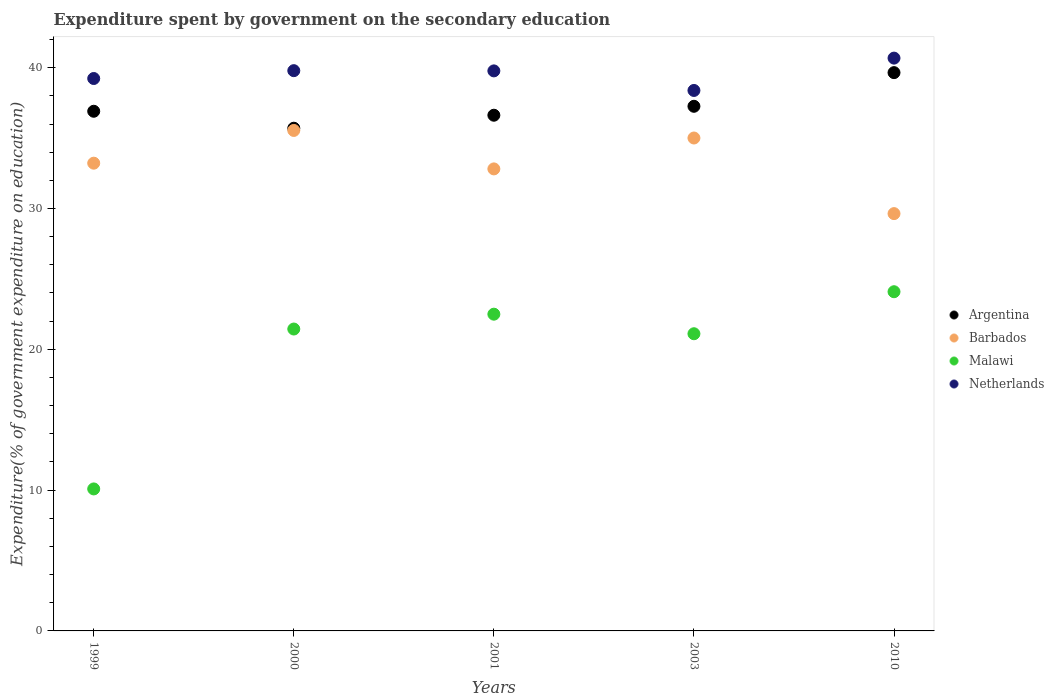How many different coloured dotlines are there?
Provide a short and direct response. 4. What is the expenditure spent by government on the secondary education in Barbados in 2000?
Your answer should be compact. 35.54. Across all years, what is the maximum expenditure spent by government on the secondary education in Argentina?
Your response must be concise. 39.65. Across all years, what is the minimum expenditure spent by government on the secondary education in Malawi?
Ensure brevity in your answer.  10.08. In which year was the expenditure spent by government on the secondary education in Argentina minimum?
Make the answer very short. 2000. What is the total expenditure spent by government on the secondary education in Argentina in the graph?
Offer a very short reply. 186.15. What is the difference between the expenditure spent by government on the secondary education in Malawi in 2001 and that in 2003?
Make the answer very short. 1.39. What is the difference between the expenditure spent by government on the secondary education in Barbados in 1999 and the expenditure spent by government on the secondary education in Argentina in 2001?
Ensure brevity in your answer.  -3.41. What is the average expenditure spent by government on the secondary education in Malawi per year?
Provide a short and direct response. 19.84. In the year 1999, what is the difference between the expenditure spent by government on the secondary education in Malawi and expenditure spent by government on the secondary education in Netherlands?
Your response must be concise. -29.15. In how many years, is the expenditure spent by government on the secondary education in Argentina greater than 40 %?
Provide a short and direct response. 0. What is the ratio of the expenditure spent by government on the secondary education in Malawi in 1999 to that in 2010?
Provide a succinct answer. 0.42. Is the difference between the expenditure spent by government on the secondary education in Malawi in 2001 and 2010 greater than the difference between the expenditure spent by government on the secondary education in Netherlands in 2001 and 2010?
Provide a short and direct response. No. What is the difference between the highest and the second highest expenditure spent by government on the secondary education in Netherlands?
Your answer should be compact. 0.89. What is the difference between the highest and the lowest expenditure spent by government on the secondary education in Barbados?
Offer a terse response. 5.91. In how many years, is the expenditure spent by government on the secondary education in Netherlands greater than the average expenditure spent by government on the secondary education in Netherlands taken over all years?
Ensure brevity in your answer.  3. Is it the case that in every year, the sum of the expenditure spent by government on the secondary education in Argentina and expenditure spent by government on the secondary education in Netherlands  is greater than the sum of expenditure spent by government on the secondary education in Malawi and expenditure spent by government on the secondary education in Barbados?
Give a very brief answer. No. Is the expenditure spent by government on the secondary education in Malawi strictly greater than the expenditure spent by government on the secondary education in Barbados over the years?
Your answer should be very brief. No. Is the expenditure spent by government on the secondary education in Argentina strictly less than the expenditure spent by government on the secondary education in Netherlands over the years?
Keep it short and to the point. Yes. How many dotlines are there?
Provide a succinct answer. 4. How many years are there in the graph?
Offer a very short reply. 5. What is the difference between two consecutive major ticks on the Y-axis?
Make the answer very short. 10. Are the values on the major ticks of Y-axis written in scientific E-notation?
Make the answer very short. No. Does the graph contain any zero values?
Provide a short and direct response. No. Does the graph contain grids?
Provide a short and direct response. No. How are the legend labels stacked?
Provide a succinct answer. Vertical. What is the title of the graph?
Provide a succinct answer. Expenditure spent by government on the secondary education. Does "Czech Republic" appear as one of the legend labels in the graph?
Offer a very short reply. No. What is the label or title of the Y-axis?
Keep it short and to the point. Expenditure(% of government expenditure on education). What is the Expenditure(% of government expenditure on education) of Argentina in 1999?
Your answer should be very brief. 36.91. What is the Expenditure(% of government expenditure on education) in Barbados in 1999?
Offer a terse response. 33.22. What is the Expenditure(% of government expenditure on education) in Malawi in 1999?
Your response must be concise. 10.08. What is the Expenditure(% of government expenditure on education) of Netherlands in 1999?
Your response must be concise. 39.23. What is the Expenditure(% of government expenditure on education) in Argentina in 2000?
Your answer should be very brief. 35.7. What is the Expenditure(% of government expenditure on education) in Barbados in 2000?
Ensure brevity in your answer.  35.54. What is the Expenditure(% of government expenditure on education) in Malawi in 2000?
Provide a short and direct response. 21.44. What is the Expenditure(% of government expenditure on education) in Netherlands in 2000?
Ensure brevity in your answer.  39.79. What is the Expenditure(% of government expenditure on education) in Argentina in 2001?
Ensure brevity in your answer.  36.63. What is the Expenditure(% of government expenditure on education) in Barbados in 2001?
Make the answer very short. 32.81. What is the Expenditure(% of government expenditure on education) in Malawi in 2001?
Your answer should be very brief. 22.5. What is the Expenditure(% of government expenditure on education) of Netherlands in 2001?
Offer a very short reply. 39.77. What is the Expenditure(% of government expenditure on education) of Argentina in 2003?
Keep it short and to the point. 37.26. What is the Expenditure(% of government expenditure on education) of Barbados in 2003?
Your answer should be very brief. 35.01. What is the Expenditure(% of government expenditure on education) in Malawi in 2003?
Keep it short and to the point. 21.11. What is the Expenditure(% of government expenditure on education) in Netherlands in 2003?
Offer a terse response. 38.38. What is the Expenditure(% of government expenditure on education) in Argentina in 2010?
Offer a terse response. 39.65. What is the Expenditure(% of government expenditure on education) of Barbados in 2010?
Your response must be concise. 29.64. What is the Expenditure(% of government expenditure on education) of Malawi in 2010?
Offer a very short reply. 24.09. What is the Expenditure(% of government expenditure on education) of Netherlands in 2010?
Give a very brief answer. 40.68. Across all years, what is the maximum Expenditure(% of government expenditure on education) in Argentina?
Offer a very short reply. 39.65. Across all years, what is the maximum Expenditure(% of government expenditure on education) of Barbados?
Provide a succinct answer. 35.54. Across all years, what is the maximum Expenditure(% of government expenditure on education) in Malawi?
Keep it short and to the point. 24.09. Across all years, what is the maximum Expenditure(% of government expenditure on education) in Netherlands?
Give a very brief answer. 40.68. Across all years, what is the minimum Expenditure(% of government expenditure on education) in Argentina?
Provide a succinct answer. 35.7. Across all years, what is the minimum Expenditure(% of government expenditure on education) in Barbados?
Your response must be concise. 29.64. Across all years, what is the minimum Expenditure(% of government expenditure on education) in Malawi?
Provide a short and direct response. 10.08. Across all years, what is the minimum Expenditure(% of government expenditure on education) of Netherlands?
Provide a short and direct response. 38.38. What is the total Expenditure(% of government expenditure on education) in Argentina in the graph?
Offer a terse response. 186.15. What is the total Expenditure(% of government expenditure on education) of Barbados in the graph?
Provide a short and direct response. 166.22. What is the total Expenditure(% of government expenditure on education) in Malawi in the graph?
Your answer should be compact. 99.22. What is the total Expenditure(% of government expenditure on education) in Netherlands in the graph?
Your answer should be very brief. 197.86. What is the difference between the Expenditure(% of government expenditure on education) of Argentina in 1999 and that in 2000?
Your answer should be compact. 1.2. What is the difference between the Expenditure(% of government expenditure on education) in Barbados in 1999 and that in 2000?
Provide a short and direct response. -2.32. What is the difference between the Expenditure(% of government expenditure on education) in Malawi in 1999 and that in 2000?
Ensure brevity in your answer.  -11.36. What is the difference between the Expenditure(% of government expenditure on education) of Netherlands in 1999 and that in 2000?
Give a very brief answer. -0.56. What is the difference between the Expenditure(% of government expenditure on education) of Argentina in 1999 and that in 2001?
Offer a very short reply. 0.28. What is the difference between the Expenditure(% of government expenditure on education) of Barbados in 1999 and that in 2001?
Keep it short and to the point. 0.41. What is the difference between the Expenditure(% of government expenditure on education) in Malawi in 1999 and that in 2001?
Your answer should be compact. -12.41. What is the difference between the Expenditure(% of government expenditure on education) of Netherlands in 1999 and that in 2001?
Ensure brevity in your answer.  -0.54. What is the difference between the Expenditure(% of government expenditure on education) in Argentina in 1999 and that in 2003?
Keep it short and to the point. -0.35. What is the difference between the Expenditure(% of government expenditure on education) in Barbados in 1999 and that in 2003?
Ensure brevity in your answer.  -1.79. What is the difference between the Expenditure(% of government expenditure on education) in Malawi in 1999 and that in 2003?
Provide a short and direct response. -11.02. What is the difference between the Expenditure(% of government expenditure on education) of Netherlands in 1999 and that in 2003?
Keep it short and to the point. 0.85. What is the difference between the Expenditure(% of government expenditure on education) in Argentina in 1999 and that in 2010?
Your response must be concise. -2.74. What is the difference between the Expenditure(% of government expenditure on education) in Barbados in 1999 and that in 2010?
Provide a succinct answer. 3.58. What is the difference between the Expenditure(% of government expenditure on education) in Malawi in 1999 and that in 2010?
Offer a terse response. -14.01. What is the difference between the Expenditure(% of government expenditure on education) in Netherlands in 1999 and that in 2010?
Provide a succinct answer. -1.45. What is the difference between the Expenditure(% of government expenditure on education) in Argentina in 2000 and that in 2001?
Keep it short and to the point. -0.92. What is the difference between the Expenditure(% of government expenditure on education) in Barbados in 2000 and that in 2001?
Offer a terse response. 2.73. What is the difference between the Expenditure(% of government expenditure on education) of Malawi in 2000 and that in 2001?
Your answer should be very brief. -1.05. What is the difference between the Expenditure(% of government expenditure on education) of Netherlands in 2000 and that in 2001?
Your answer should be very brief. 0.02. What is the difference between the Expenditure(% of government expenditure on education) in Argentina in 2000 and that in 2003?
Give a very brief answer. -1.56. What is the difference between the Expenditure(% of government expenditure on education) in Barbados in 2000 and that in 2003?
Provide a short and direct response. 0.54. What is the difference between the Expenditure(% of government expenditure on education) of Malawi in 2000 and that in 2003?
Your answer should be compact. 0.33. What is the difference between the Expenditure(% of government expenditure on education) in Netherlands in 2000 and that in 2003?
Offer a terse response. 1.41. What is the difference between the Expenditure(% of government expenditure on education) of Argentina in 2000 and that in 2010?
Your answer should be compact. -3.95. What is the difference between the Expenditure(% of government expenditure on education) in Barbados in 2000 and that in 2010?
Ensure brevity in your answer.  5.91. What is the difference between the Expenditure(% of government expenditure on education) of Malawi in 2000 and that in 2010?
Provide a succinct answer. -2.65. What is the difference between the Expenditure(% of government expenditure on education) of Netherlands in 2000 and that in 2010?
Offer a terse response. -0.89. What is the difference between the Expenditure(% of government expenditure on education) in Argentina in 2001 and that in 2003?
Your answer should be compact. -0.63. What is the difference between the Expenditure(% of government expenditure on education) of Barbados in 2001 and that in 2003?
Provide a short and direct response. -2.19. What is the difference between the Expenditure(% of government expenditure on education) of Malawi in 2001 and that in 2003?
Provide a short and direct response. 1.39. What is the difference between the Expenditure(% of government expenditure on education) of Netherlands in 2001 and that in 2003?
Provide a succinct answer. 1.39. What is the difference between the Expenditure(% of government expenditure on education) in Argentina in 2001 and that in 2010?
Provide a short and direct response. -3.02. What is the difference between the Expenditure(% of government expenditure on education) in Barbados in 2001 and that in 2010?
Your answer should be very brief. 3.18. What is the difference between the Expenditure(% of government expenditure on education) in Malawi in 2001 and that in 2010?
Your answer should be compact. -1.59. What is the difference between the Expenditure(% of government expenditure on education) of Netherlands in 2001 and that in 2010?
Keep it short and to the point. -0.91. What is the difference between the Expenditure(% of government expenditure on education) of Argentina in 2003 and that in 2010?
Offer a terse response. -2.39. What is the difference between the Expenditure(% of government expenditure on education) in Barbados in 2003 and that in 2010?
Offer a very short reply. 5.37. What is the difference between the Expenditure(% of government expenditure on education) of Malawi in 2003 and that in 2010?
Give a very brief answer. -2.98. What is the difference between the Expenditure(% of government expenditure on education) in Netherlands in 2003 and that in 2010?
Provide a short and direct response. -2.3. What is the difference between the Expenditure(% of government expenditure on education) of Argentina in 1999 and the Expenditure(% of government expenditure on education) of Barbados in 2000?
Provide a succinct answer. 1.36. What is the difference between the Expenditure(% of government expenditure on education) in Argentina in 1999 and the Expenditure(% of government expenditure on education) in Malawi in 2000?
Provide a short and direct response. 15.47. What is the difference between the Expenditure(% of government expenditure on education) of Argentina in 1999 and the Expenditure(% of government expenditure on education) of Netherlands in 2000?
Keep it short and to the point. -2.88. What is the difference between the Expenditure(% of government expenditure on education) in Barbados in 1999 and the Expenditure(% of government expenditure on education) in Malawi in 2000?
Ensure brevity in your answer.  11.78. What is the difference between the Expenditure(% of government expenditure on education) in Barbados in 1999 and the Expenditure(% of government expenditure on education) in Netherlands in 2000?
Your answer should be compact. -6.57. What is the difference between the Expenditure(% of government expenditure on education) in Malawi in 1999 and the Expenditure(% of government expenditure on education) in Netherlands in 2000?
Your answer should be compact. -29.71. What is the difference between the Expenditure(% of government expenditure on education) in Argentina in 1999 and the Expenditure(% of government expenditure on education) in Barbados in 2001?
Provide a succinct answer. 4.09. What is the difference between the Expenditure(% of government expenditure on education) in Argentina in 1999 and the Expenditure(% of government expenditure on education) in Malawi in 2001?
Keep it short and to the point. 14.41. What is the difference between the Expenditure(% of government expenditure on education) in Argentina in 1999 and the Expenditure(% of government expenditure on education) in Netherlands in 2001?
Provide a short and direct response. -2.87. What is the difference between the Expenditure(% of government expenditure on education) of Barbados in 1999 and the Expenditure(% of government expenditure on education) of Malawi in 2001?
Give a very brief answer. 10.72. What is the difference between the Expenditure(% of government expenditure on education) in Barbados in 1999 and the Expenditure(% of government expenditure on education) in Netherlands in 2001?
Provide a short and direct response. -6.55. What is the difference between the Expenditure(% of government expenditure on education) in Malawi in 1999 and the Expenditure(% of government expenditure on education) in Netherlands in 2001?
Make the answer very short. -29.69. What is the difference between the Expenditure(% of government expenditure on education) of Argentina in 1999 and the Expenditure(% of government expenditure on education) of Barbados in 2003?
Provide a short and direct response. 1.9. What is the difference between the Expenditure(% of government expenditure on education) of Argentina in 1999 and the Expenditure(% of government expenditure on education) of Malawi in 2003?
Ensure brevity in your answer.  15.8. What is the difference between the Expenditure(% of government expenditure on education) of Argentina in 1999 and the Expenditure(% of government expenditure on education) of Netherlands in 2003?
Offer a terse response. -1.48. What is the difference between the Expenditure(% of government expenditure on education) in Barbados in 1999 and the Expenditure(% of government expenditure on education) in Malawi in 2003?
Your answer should be very brief. 12.11. What is the difference between the Expenditure(% of government expenditure on education) in Barbados in 1999 and the Expenditure(% of government expenditure on education) in Netherlands in 2003?
Your answer should be very brief. -5.16. What is the difference between the Expenditure(% of government expenditure on education) of Malawi in 1999 and the Expenditure(% of government expenditure on education) of Netherlands in 2003?
Ensure brevity in your answer.  -28.3. What is the difference between the Expenditure(% of government expenditure on education) of Argentina in 1999 and the Expenditure(% of government expenditure on education) of Barbados in 2010?
Offer a very short reply. 7.27. What is the difference between the Expenditure(% of government expenditure on education) in Argentina in 1999 and the Expenditure(% of government expenditure on education) in Malawi in 2010?
Provide a succinct answer. 12.82. What is the difference between the Expenditure(% of government expenditure on education) of Argentina in 1999 and the Expenditure(% of government expenditure on education) of Netherlands in 2010?
Offer a very short reply. -3.77. What is the difference between the Expenditure(% of government expenditure on education) in Barbados in 1999 and the Expenditure(% of government expenditure on education) in Malawi in 2010?
Make the answer very short. 9.13. What is the difference between the Expenditure(% of government expenditure on education) in Barbados in 1999 and the Expenditure(% of government expenditure on education) in Netherlands in 2010?
Give a very brief answer. -7.46. What is the difference between the Expenditure(% of government expenditure on education) of Malawi in 1999 and the Expenditure(% of government expenditure on education) of Netherlands in 2010?
Ensure brevity in your answer.  -30.6. What is the difference between the Expenditure(% of government expenditure on education) of Argentina in 2000 and the Expenditure(% of government expenditure on education) of Barbados in 2001?
Ensure brevity in your answer.  2.89. What is the difference between the Expenditure(% of government expenditure on education) of Argentina in 2000 and the Expenditure(% of government expenditure on education) of Malawi in 2001?
Your answer should be compact. 13.21. What is the difference between the Expenditure(% of government expenditure on education) of Argentina in 2000 and the Expenditure(% of government expenditure on education) of Netherlands in 2001?
Provide a short and direct response. -4.07. What is the difference between the Expenditure(% of government expenditure on education) of Barbados in 2000 and the Expenditure(% of government expenditure on education) of Malawi in 2001?
Ensure brevity in your answer.  13.05. What is the difference between the Expenditure(% of government expenditure on education) of Barbados in 2000 and the Expenditure(% of government expenditure on education) of Netherlands in 2001?
Your answer should be very brief. -4.23. What is the difference between the Expenditure(% of government expenditure on education) of Malawi in 2000 and the Expenditure(% of government expenditure on education) of Netherlands in 2001?
Offer a terse response. -18.33. What is the difference between the Expenditure(% of government expenditure on education) in Argentina in 2000 and the Expenditure(% of government expenditure on education) in Barbados in 2003?
Your response must be concise. 0.7. What is the difference between the Expenditure(% of government expenditure on education) in Argentina in 2000 and the Expenditure(% of government expenditure on education) in Malawi in 2003?
Keep it short and to the point. 14.6. What is the difference between the Expenditure(% of government expenditure on education) in Argentina in 2000 and the Expenditure(% of government expenditure on education) in Netherlands in 2003?
Offer a terse response. -2.68. What is the difference between the Expenditure(% of government expenditure on education) in Barbados in 2000 and the Expenditure(% of government expenditure on education) in Malawi in 2003?
Offer a terse response. 14.44. What is the difference between the Expenditure(% of government expenditure on education) of Barbados in 2000 and the Expenditure(% of government expenditure on education) of Netherlands in 2003?
Give a very brief answer. -2.84. What is the difference between the Expenditure(% of government expenditure on education) of Malawi in 2000 and the Expenditure(% of government expenditure on education) of Netherlands in 2003?
Provide a short and direct response. -16.94. What is the difference between the Expenditure(% of government expenditure on education) of Argentina in 2000 and the Expenditure(% of government expenditure on education) of Barbados in 2010?
Provide a succinct answer. 6.07. What is the difference between the Expenditure(% of government expenditure on education) in Argentina in 2000 and the Expenditure(% of government expenditure on education) in Malawi in 2010?
Make the answer very short. 11.61. What is the difference between the Expenditure(% of government expenditure on education) of Argentina in 2000 and the Expenditure(% of government expenditure on education) of Netherlands in 2010?
Provide a short and direct response. -4.98. What is the difference between the Expenditure(% of government expenditure on education) of Barbados in 2000 and the Expenditure(% of government expenditure on education) of Malawi in 2010?
Offer a very short reply. 11.45. What is the difference between the Expenditure(% of government expenditure on education) in Barbados in 2000 and the Expenditure(% of government expenditure on education) in Netherlands in 2010?
Provide a succinct answer. -5.14. What is the difference between the Expenditure(% of government expenditure on education) in Malawi in 2000 and the Expenditure(% of government expenditure on education) in Netherlands in 2010?
Your answer should be compact. -19.24. What is the difference between the Expenditure(% of government expenditure on education) in Argentina in 2001 and the Expenditure(% of government expenditure on education) in Barbados in 2003?
Your response must be concise. 1.62. What is the difference between the Expenditure(% of government expenditure on education) in Argentina in 2001 and the Expenditure(% of government expenditure on education) in Malawi in 2003?
Make the answer very short. 15.52. What is the difference between the Expenditure(% of government expenditure on education) in Argentina in 2001 and the Expenditure(% of government expenditure on education) in Netherlands in 2003?
Give a very brief answer. -1.76. What is the difference between the Expenditure(% of government expenditure on education) in Barbados in 2001 and the Expenditure(% of government expenditure on education) in Malawi in 2003?
Your answer should be compact. 11.71. What is the difference between the Expenditure(% of government expenditure on education) in Barbados in 2001 and the Expenditure(% of government expenditure on education) in Netherlands in 2003?
Provide a succinct answer. -5.57. What is the difference between the Expenditure(% of government expenditure on education) of Malawi in 2001 and the Expenditure(% of government expenditure on education) of Netherlands in 2003?
Keep it short and to the point. -15.89. What is the difference between the Expenditure(% of government expenditure on education) of Argentina in 2001 and the Expenditure(% of government expenditure on education) of Barbados in 2010?
Give a very brief answer. 6.99. What is the difference between the Expenditure(% of government expenditure on education) of Argentina in 2001 and the Expenditure(% of government expenditure on education) of Malawi in 2010?
Provide a short and direct response. 12.54. What is the difference between the Expenditure(% of government expenditure on education) in Argentina in 2001 and the Expenditure(% of government expenditure on education) in Netherlands in 2010?
Keep it short and to the point. -4.06. What is the difference between the Expenditure(% of government expenditure on education) in Barbados in 2001 and the Expenditure(% of government expenditure on education) in Malawi in 2010?
Make the answer very short. 8.72. What is the difference between the Expenditure(% of government expenditure on education) in Barbados in 2001 and the Expenditure(% of government expenditure on education) in Netherlands in 2010?
Offer a very short reply. -7.87. What is the difference between the Expenditure(% of government expenditure on education) in Malawi in 2001 and the Expenditure(% of government expenditure on education) in Netherlands in 2010?
Offer a very short reply. -18.19. What is the difference between the Expenditure(% of government expenditure on education) of Argentina in 2003 and the Expenditure(% of government expenditure on education) of Barbados in 2010?
Offer a terse response. 7.62. What is the difference between the Expenditure(% of government expenditure on education) in Argentina in 2003 and the Expenditure(% of government expenditure on education) in Malawi in 2010?
Your answer should be compact. 13.17. What is the difference between the Expenditure(% of government expenditure on education) in Argentina in 2003 and the Expenditure(% of government expenditure on education) in Netherlands in 2010?
Your answer should be compact. -3.42. What is the difference between the Expenditure(% of government expenditure on education) in Barbados in 2003 and the Expenditure(% of government expenditure on education) in Malawi in 2010?
Your response must be concise. 10.92. What is the difference between the Expenditure(% of government expenditure on education) in Barbados in 2003 and the Expenditure(% of government expenditure on education) in Netherlands in 2010?
Provide a short and direct response. -5.67. What is the difference between the Expenditure(% of government expenditure on education) of Malawi in 2003 and the Expenditure(% of government expenditure on education) of Netherlands in 2010?
Keep it short and to the point. -19.57. What is the average Expenditure(% of government expenditure on education) in Argentina per year?
Provide a succinct answer. 37.23. What is the average Expenditure(% of government expenditure on education) in Barbados per year?
Make the answer very short. 33.24. What is the average Expenditure(% of government expenditure on education) of Malawi per year?
Offer a terse response. 19.84. What is the average Expenditure(% of government expenditure on education) of Netherlands per year?
Make the answer very short. 39.57. In the year 1999, what is the difference between the Expenditure(% of government expenditure on education) in Argentina and Expenditure(% of government expenditure on education) in Barbados?
Ensure brevity in your answer.  3.69. In the year 1999, what is the difference between the Expenditure(% of government expenditure on education) in Argentina and Expenditure(% of government expenditure on education) in Malawi?
Your answer should be very brief. 26.82. In the year 1999, what is the difference between the Expenditure(% of government expenditure on education) in Argentina and Expenditure(% of government expenditure on education) in Netherlands?
Your response must be concise. -2.33. In the year 1999, what is the difference between the Expenditure(% of government expenditure on education) of Barbados and Expenditure(% of government expenditure on education) of Malawi?
Provide a succinct answer. 23.14. In the year 1999, what is the difference between the Expenditure(% of government expenditure on education) in Barbados and Expenditure(% of government expenditure on education) in Netherlands?
Your answer should be compact. -6.01. In the year 1999, what is the difference between the Expenditure(% of government expenditure on education) of Malawi and Expenditure(% of government expenditure on education) of Netherlands?
Give a very brief answer. -29.15. In the year 2000, what is the difference between the Expenditure(% of government expenditure on education) in Argentina and Expenditure(% of government expenditure on education) in Barbados?
Keep it short and to the point. 0.16. In the year 2000, what is the difference between the Expenditure(% of government expenditure on education) in Argentina and Expenditure(% of government expenditure on education) in Malawi?
Ensure brevity in your answer.  14.26. In the year 2000, what is the difference between the Expenditure(% of government expenditure on education) in Argentina and Expenditure(% of government expenditure on education) in Netherlands?
Offer a very short reply. -4.09. In the year 2000, what is the difference between the Expenditure(% of government expenditure on education) in Barbados and Expenditure(% of government expenditure on education) in Malawi?
Give a very brief answer. 14.1. In the year 2000, what is the difference between the Expenditure(% of government expenditure on education) in Barbados and Expenditure(% of government expenditure on education) in Netherlands?
Your answer should be very brief. -4.25. In the year 2000, what is the difference between the Expenditure(% of government expenditure on education) in Malawi and Expenditure(% of government expenditure on education) in Netherlands?
Your response must be concise. -18.35. In the year 2001, what is the difference between the Expenditure(% of government expenditure on education) in Argentina and Expenditure(% of government expenditure on education) in Barbados?
Keep it short and to the point. 3.81. In the year 2001, what is the difference between the Expenditure(% of government expenditure on education) of Argentina and Expenditure(% of government expenditure on education) of Malawi?
Keep it short and to the point. 14.13. In the year 2001, what is the difference between the Expenditure(% of government expenditure on education) in Argentina and Expenditure(% of government expenditure on education) in Netherlands?
Provide a succinct answer. -3.15. In the year 2001, what is the difference between the Expenditure(% of government expenditure on education) of Barbados and Expenditure(% of government expenditure on education) of Malawi?
Your response must be concise. 10.32. In the year 2001, what is the difference between the Expenditure(% of government expenditure on education) of Barbados and Expenditure(% of government expenditure on education) of Netherlands?
Your response must be concise. -6.96. In the year 2001, what is the difference between the Expenditure(% of government expenditure on education) in Malawi and Expenditure(% of government expenditure on education) in Netherlands?
Your answer should be very brief. -17.28. In the year 2003, what is the difference between the Expenditure(% of government expenditure on education) in Argentina and Expenditure(% of government expenditure on education) in Barbados?
Provide a short and direct response. 2.25. In the year 2003, what is the difference between the Expenditure(% of government expenditure on education) in Argentina and Expenditure(% of government expenditure on education) in Malawi?
Provide a succinct answer. 16.15. In the year 2003, what is the difference between the Expenditure(% of government expenditure on education) of Argentina and Expenditure(% of government expenditure on education) of Netherlands?
Your response must be concise. -1.12. In the year 2003, what is the difference between the Expenditure(% of government expenditure on education) of Barbados and Expenditure(% of government expenditure on education) of Malawi?
Provide a short and direct response. 13.9. In the year 2003, what is the difference between the Expenditure(% of government expenditure on education) of Barbados and Expenditure(% of government expenditure on education) of Netherlands?
Make the answer very short. -3.38. In the year 2003, what is the difference between the Expenditure(% of government expenditure on education) in Malawi and Expenditure(% of government expenditure on education) in Netherlands?
Give a very brief answer. -17.28. In the year 2010, what is the difference between the Expenditure(% of government expenditure on education) in Argentina and Expenditure(% of government expenditure on education) in Barbados?
Provide a short and direct response. 10.01. In the year 2010, what is the difference between the Expenditure(% of government expenditure on education) of Argentina and Expenditure(% of government expenditure on education) of Malawi?
Your answer should be very brief. 15.56. In the year 2010, what is the difference between the Expenditure(% of government expenditure on education) of Argentina and Expenditure(% of government expenditure on education) of Netherlands?
Offer a terse response. -1.03. In the year 2010, what is the difference between the Expenditure(% of government expenditure on education) of Barbados and Expenditure(% of government expenditure on education) of Malawi?
Provide a short and direct response. 5.55. In the year 2010, what is the difference between the Expenditure(% of government expenditure on education) of Barbados and Expenditure(% of government expenditure on education) of Netherlands?
Keep it short and to the point. -11.04. In the year 2010, what is the difference between the Expenditure(% of government expenditure on education) in Malawi and Expenditure(% of government expenditure on education) in Netherlands?
Provide a short and direct response. -16.59. What is the ratio of the Expenditure(% of government expenditure on education) in Argentina in 1999 to that in 2000?
Your response must be concise. 1.03. What is the ratio of the Expenditure(% of government expenditure on education) in Barbados in 1999 to that in 2000?
Your answer should be very brief. 0.93. What is the ratio of the Expenditure(% of government expenditure on education) in Malawi in 1999 to that in 2000?
Give a very brief answer. 0.47. What is the ratio of the Expenditure(% of government expenditure on education) in Netherlands in 1999 to that in 2000?
Provide a succinct answer. 0.99. What is the ratio of the Expenditure(% of government expenditure on education) in Argentina in 1999 to that in 2001?
Your answer should be very brief. 1.01. What is the ratio of the Expenditure(% of government expenditure on education) in Barbados in 1999 to that in 2001?
Offer a terse response. 1.01. What is the ratio of the Expenditure(% of government expenditure on education) of Malawi in 1999 to that in 2001?
Your response must be concise. 0.45. What is the ratio of the Expenditure(% of government expenditure on education) of Netherlands in 1999 to that in 2001?
Offer a very short reply. 0.99. What is the ratio of the Expenditure(% of government expenditure on education) in Barbados in 1999 to that in 2003?
Make the answer very short. 0.95. What is the ratio of the Expenditure(% of government expenditure on education) of Malawi in 1999 to that in 2003?
Offer a terse response. 0.48. What is the ratio of the Expenditure(% of government expenditure on education) in Netherlands in 1999 to that in 2003?
Keep it short and to the point. 1.02. What is the ratio of the Expenditure(% of government expenditure on education) of Argentina in 1999 to that in 2010?
Ensure brevity in your answer.  0.93. What is the ratio of the Expenditure(% of government expenditure on education) in Barbados in 1999 to that in 2010?
Your answer should be very brief. 1.12. What is the ratio of the Expenditure(% of government expenditure on education) of Malawi in 1999 to that in 2010?
Give a very brief answer. 0.42. What is the ratio of the Expenditure(% of government expenditure on education) in Netherlands in 1999 to that in 2010?
Offer a terse response. 0.96. What is the ratio of the Expenditure(% of government expenditure on education) of Argentina in 2000 to that in 2001?
Your response must be concise. 0.97. What is the ratio of the Expenditure(% of government expenditure on education) in Barbados in 2000 to that in 2001?
Keep it short and to the point. 1.08. What is the ratio of the Expenditure(% of government expenditure on education) of Malawi in 2000 to that in 2001?
Offer a terse response. 0.95. What is the ratio of the Expenditure(% of government expenditure on education) of Argentina in 2000 to that in 2003?
Your answer should be compact. 0.96. What is the ratio of the Expenditure(% of government expenditure on education) in Barbados in 2000 to that in 2003?
Your answer should be very brief. 1.02. What is the ratio of the Expenditure(% of government expenditure on education) in Malawi in 2000 to that in 2003?
Keep it short and to the point. 1.02. What is the ratio of the Expenditure(% of government expenditure on education) of Netherlands in 2000 to that in 2003?
Your answer should be compact. 1.04. What is the ratio of the Expenditure(% of government expenditure on education) in Argentina in 2000 to that in 2010?
Keep it short and to the point. 0.9. What is the ratio of the Expenditure(% of government expenditure on education) in Barbados in 2000 to that in 2010?
Provide a succinct answer. 1.2. What is the ratio of the Expenditure(% of government expenditure on education) in Malawi in 2000 to that in 2010?
Your answer should be compact. 0.89. What is the ratio of the Expenditure(% of government expenditure on education) in Netherlands in 2000 to that in 2010?
Your answer should be very brief. 0.98. What is the ratio of the Expenditure(% of government expenditure on education) in Barbados in 2001 to that in 2003?
Keep it short and to the point. 0.94. What is the ratio of the Expenditure(% of government expenditure on education) of Malawi in 2001 to that in 2003?
Ensure brevity in your answer.  1.07. What is the ratio of the Expenditure(% of government expenditure on education) in Netherlands in 2001 to that in 2003?
Give a very brief answer. 1.04. What is the ratio of the Expenditure(% of government expenditure on education) in Argentina in 2001 to that in 2010?
Make the answer very short. 0.92. What is the ratio of the Expenditure(% of government expenditure on education) in Barbados in 2001 to that in 2010?
Make the answer very short. 1.11. What is the ratio of the Expenditure(% of government expenditure on education) of Malawi in 2001 to that in 2010?
Give a very brief answer. 0.93. What is the ratio of the Expenditure(% of government expenditure on education) of Netherlands in 2001 to that in 2010?
Your response must be concise. 0.98. What is the ratio of the Expenditure(% of government expenditure on education) of Argentina in 2003 to that in 2010?
Ensure brevity in your answer.  0.94. What is the ratio of the Expenditure(% of government expenditure on education) of Barbados in 2003 to that in 2010?
Offer a very short reply. 1.18. What is the ratio of the Expenditure(% of government expenditure on education) of Malawi in 2003 to that in 2010?
Your answer should be compact. 0.88. What is the ratio of the Expenditure(% of government expenditure on education) in Netherlands in 2003 to that in 2010?
Provide a succinct answer. 0.94. What is the difference between the highest and the second highest Expenditure(% of government expenditure on education) in Argentina?
Keep it short and to the point. 2.39. What is the difference between the highest and the second highest Expenditure(% of government expenditure on education) in Barbados?
Make the answer very short. 0.54. What is the difference between the highest and the second highest Expenditure(% of government expenditure on education) in Malawi?
Keep it short and to the point. 1.59. What is the difference between the highest and the second highest Expenditure(% of government expenditure on education) in Netherlands?
Your answer should be very brief. 0.89. What is the difference between the highest and the lowest Expenditure(% of government expenditure on education) of Argentina?
Offer a terse response. 3.95. What is the difference between the highest and the lowest Expenditure(% of government expenditure on education) in Barbados?
Provide a short and direct response. 5.91. What is the difference between the highest and the lowest Expenditure(% of government expenditure on education) in Malawi?
Keep it short and to the point. 14.01. What is the difference between the highest and the lowest Expenditure(% of government expenditure on education) of Netherlands?
Give a very brief answer. 2.3. 